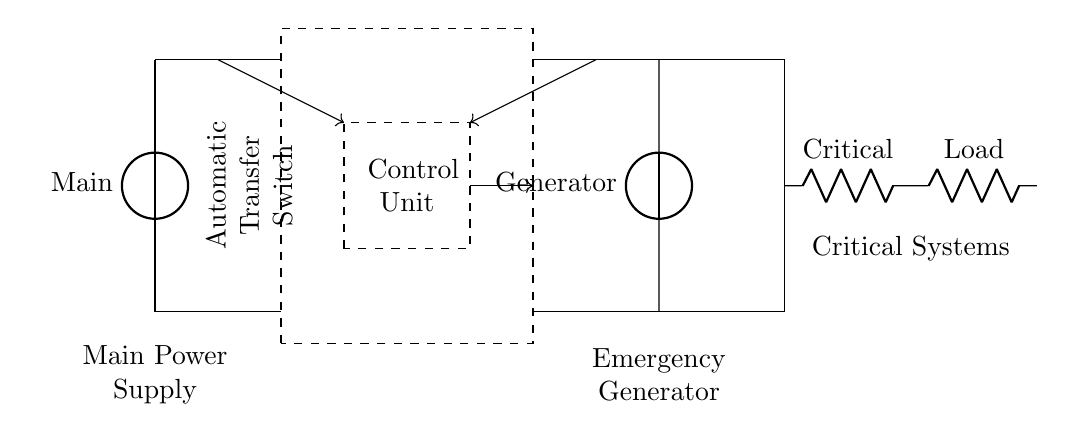What is the component used for the main power supply? The diagram shows a voltage source labeled "Main," which serves as the component providing the primary electrical supply to the circuit.
Answer: Main What is the purpose of the dashed rectangle in the circuit? The dashed rectangle represents the Automatic Transfer Switch, which facilitates the switching of power sources between the main supply and the emergency generator when needed.
Answer: Automatic Transfer Switch How many resistors are connected to the critical systems? There are two resistors labeled "Critical" and "Load" in series, which indicates they both contribute to the critical load that the circuit supports.
Answer: Two Which component receives input from both the main power supply and the emergency generator? The Automatic Transfer Switch receives input from both sources, as it is designed to switch between them to provide uninterrupted power.
Answer: Automatic Transfer Switch What signifies the control unit in the circuit? The control unit is represented by a dashed rectangle indicating the component responsible for controlling the operation of the Automatic Transfer Switch based on power availability.
Answer: Control Unit What happens to the circuit when the main power fails? When the main power fails, the Automatic Transfer Switch automatically switches to the emergency generator to maintain power to the critical systems.
Answer: Switches to generator What is the total connection from the generator to the critical systems? The generator is connected to the critical systems through the Automatic Transfer Switch, which allows the selected power source to deliver power to the critical load.
Answer: Automatic Transfer Switch to Critical Systems 